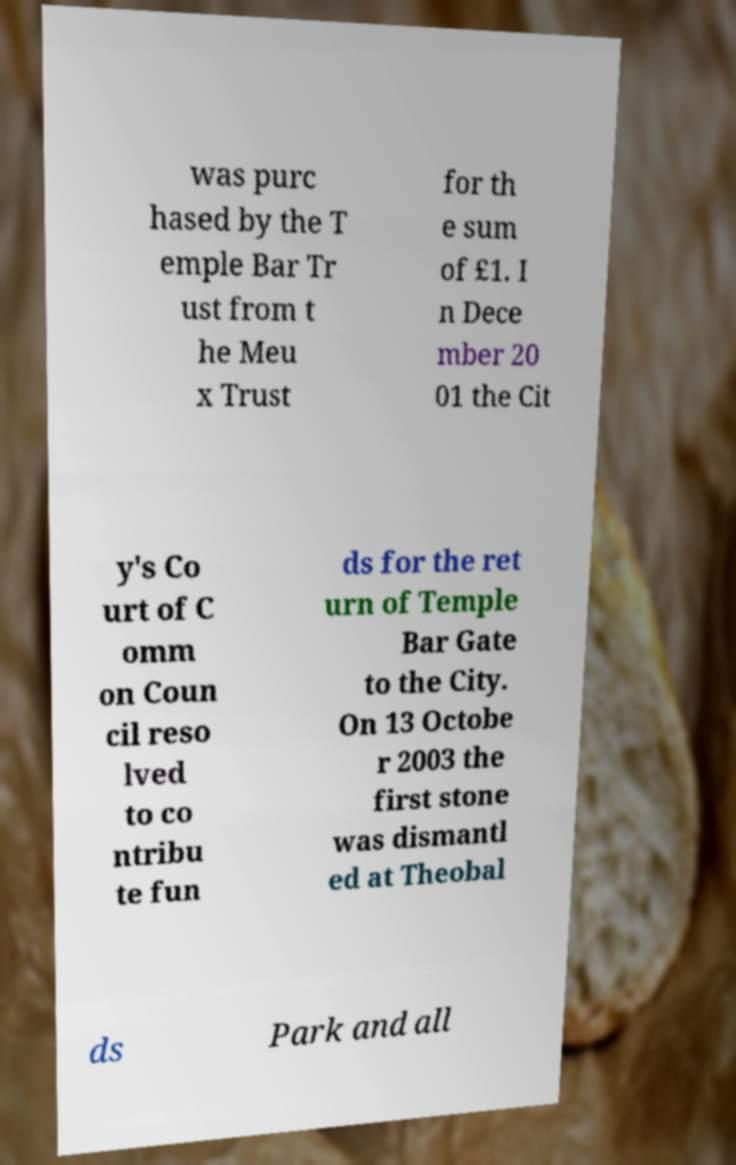Could you extract and type out the text from this image? was purc hased by the T emple Bar Tr ust from t he Meu x Trust for th e sum of £1. I n Dece mber 20 01 the Cit y's Co urt of C omm on Coun cil reso lved to co ntribu te fun ds for the ret urn of Temple Bar Gate to the City. On 13 Octobe r 2003 the first stone was dismantl ed at Theobal ds Park and all 